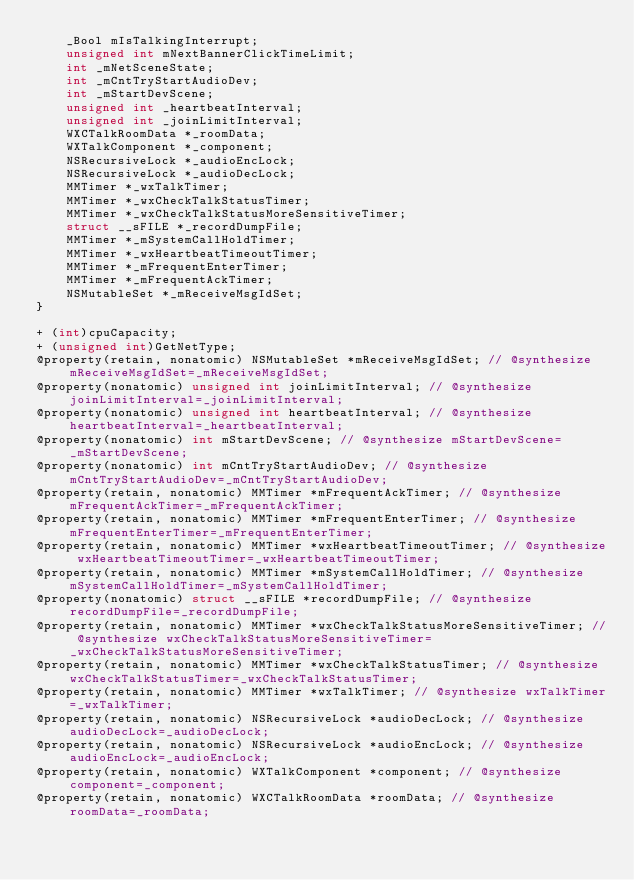<code> <loc_0><loc_0><loc_500><loc_500><_C_>    _Bool mIsTalkingInterrupt;
    unsigned int mNextBannerClickTimeLimit;
    int _mNetSceneState;
    int _mCntTryStartAudioDev;
    int _mStartDevScene;
    unsigned int _heartbeatInterval;
    unsigned int _joinLimitInterval;
    WXCTalkRoomData *_roomData;
    WXTalkComponent *_component;
    NSRecursiveLock *_audioEncLock;
    NSRecursiveLock *_audioDecLock;
    MMTimer *_wxTalkTimer;
    MMTimer *_wxCheckTalkStatusTimer;
    MMTimer *_wxCheckTalkStatusMoreSensitiveTimer;
    struct __sFILE *_recordDumpFile;
    MMTimer *_mSystemCallHoldTimer;
    MMTimer *_wxHeartbeatTimeoutTimer;
    MMTimer *_mFrequentEnterTimer;
    MMTimer *_mFrequentAckTimer;
    NSMutableSet *_mReceiveMsgIdSet;
}

+ (int)cpuCapacity;
+ (unsigned int)GetNetType;
@property(retain, nonatomic) NSMutableSet *mReceiveMsgIdSet; // @synthesize mReceiveMsgIdSet=_mReceiveMsgIdSet;
@property(nonatomic) unsigned int joinLimitInterval; // @synthesize joinLimitInterval=_joinLimitInterval;
@property(nonatomic) unsigned int heartbeatInterval; // @synthesize heartbeatInterval=_heartbeatInterval;
@property(nonatomic) int mStartDevScene; // @synthesize mStartDevScene=_mStartDevScene;
@property(nonatomic) int mCntTryStartAudioDev; // @synthesize mCntTryStartAudioDev=_mCntTryStartAudioDev;
@property(retain, nonatomic) MMTimer *mFrequentAckTimer; // @synthesize mFrequentAckTimer=_mFrequentAckTimer;
@property(retain, nonatomic) MMTimer *mFrequentEnterTimer; // @synthesize mFrequentEnterTimer=_mFrequentEnterTimer;
@property(retain, nonatomic) MMTimer *wxHeartbeatTimeoutTimer; // @synthesize wxHeartbeatTimeoutTimer=_wxHeartbeatTimeoutTimer;
@property(retain, nonatomic) MMTimer *mSystemCallHoldTimer; // @synthesize mSystemCallHoldTimer=_mSystemCallHoldTimer;
@property(nonatomic) struct __sFILE *recordDumpFile; // @synthesize recordDumpFile=_recordDumpFile;
@property(retain, nonatomic) MMTimer *wxCheckTalkStatusMoreSensitiveTimer; // @synthesize wxCheckTalkStatusMoreSensitiveTimer=_wxCheckTalkStatusMoreSensitiveTimer;
@property(retain, nonatomic) MMTimer *wxCheckTalkStatusTimer; // @synthesize wxCheckTalkStatusTimer=_wxCheckTalkStatusTimer;
@property(retain, nonatomic) MMTimer *wxTalkTimer; // @synthesize wxTalkTimer=_wxTalkTimer;
@property(retain, nonatomic) NSRecursiveLock *audioDecLock; // @synthesize audioDecLock=_audioDecLock;
@property(retain, nonatomic) NSRecursiveLock *audioEncLock; // @synthesize audioEncLock=_audioEncLock;
@property(retain, nonatomic) WXTalkComponent *component; // @synthesize component=_component;
@property(retain, nonatomic) WXCTalkRoomData *roomData; // @synthesize roomData=_roomData;</code> 